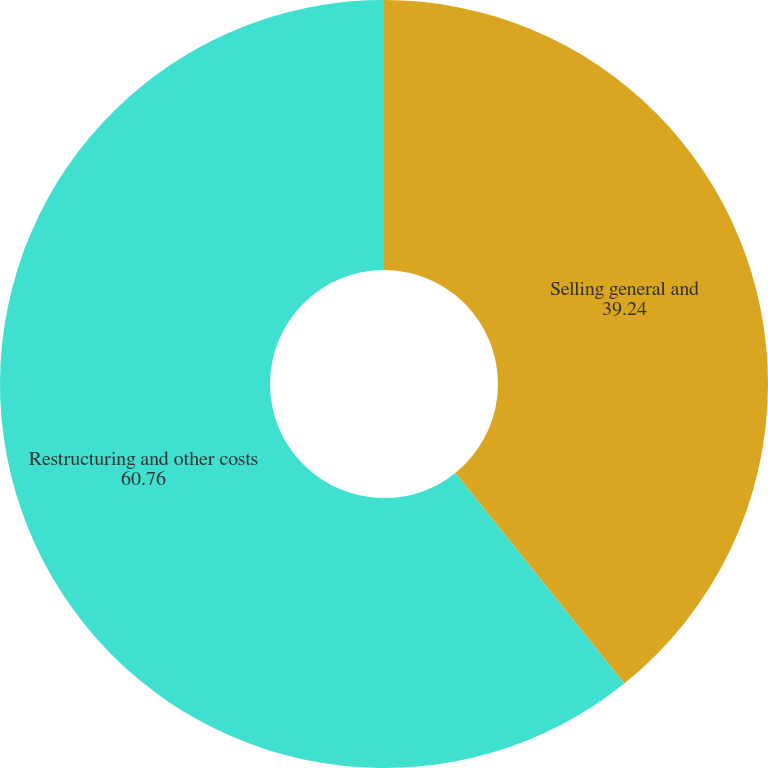<chart> <loc_0><loc_0><loc_500><loc_500><pie_chart><fcel>Selling general and<fcel>Restructuring and other costs<nl><fcel>39.24%<fcel>60.76%<nl></chart> 